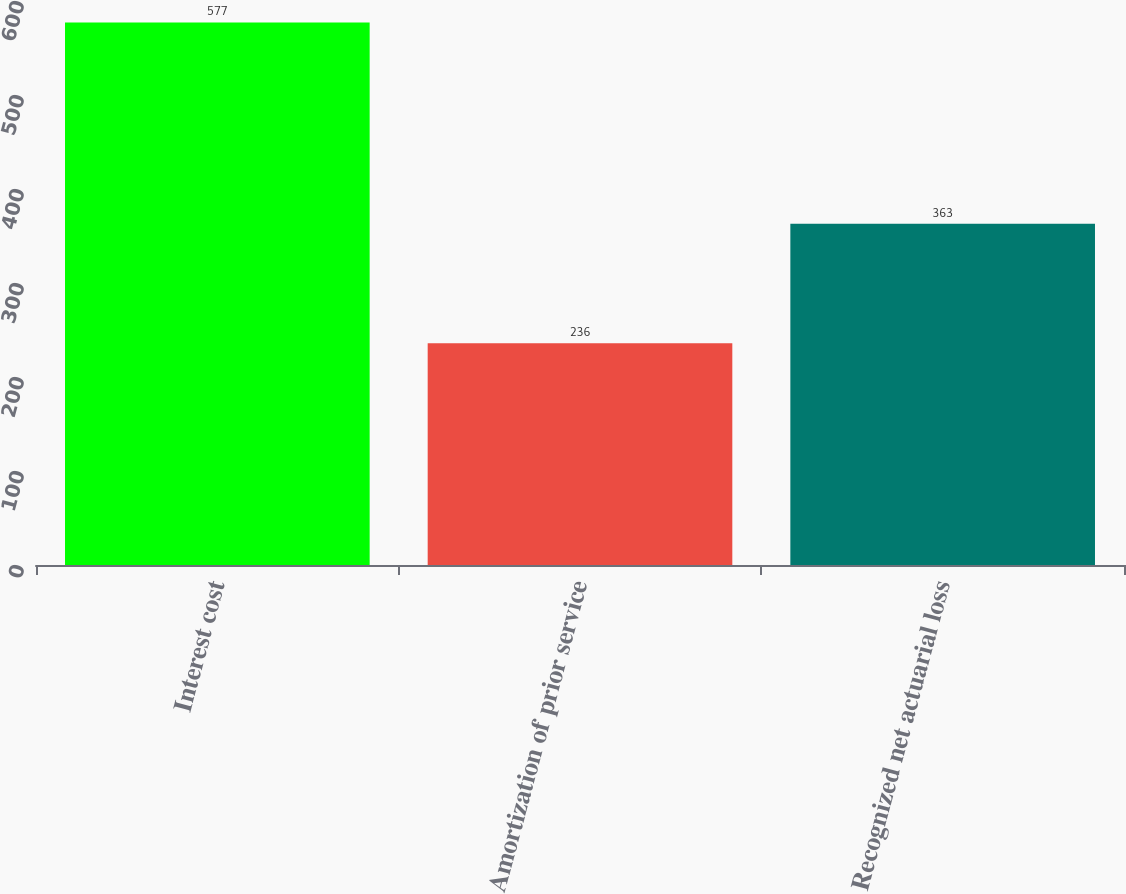<chart> <loc_0><loc_0><loc_500><loc_500><bar_chart><fcel>Interest cost<fcel>Amortization of prior service<fcel>Recognized net actuarial loss<nl><fcel>577<fcel>236<fcel>363<nl></chart> 